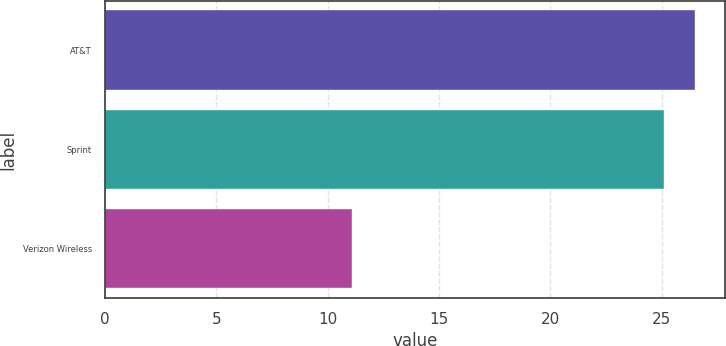<chart> <loc_0><loc_0><loc_500><loc_500><bar_chart><fcel>AT&T<fcel>Sprint<fcel>Verizon Wireless<nl><fcel>26.52<fcel>25.1<fcel>11.1<nl></chart> 